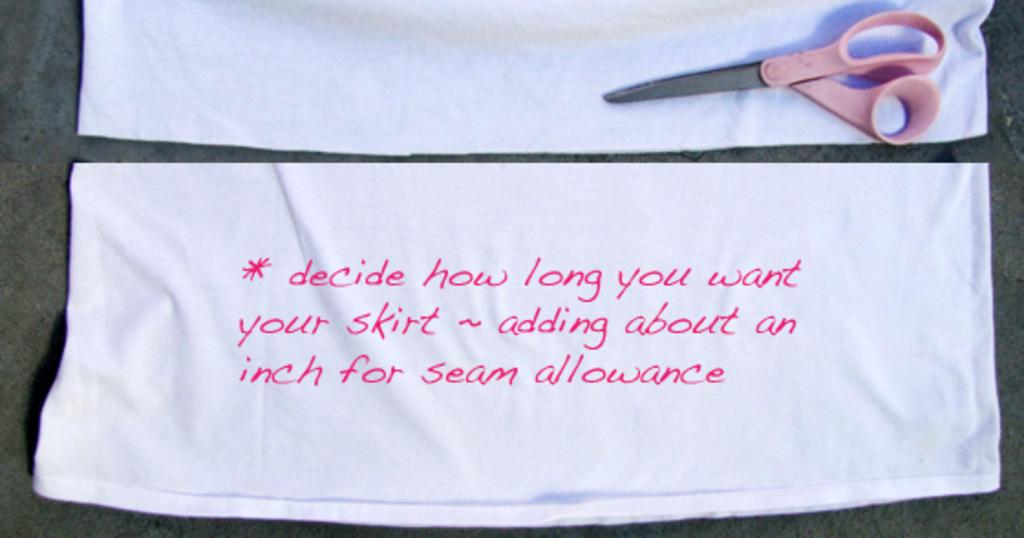What is written or printed on the white cloth in the image? There is text on a white cloth in the image. What object is placed on another white cloth in the image? There is a scissor on another white cloth in the image. What can be seen in the background of the image? There is a plain surface visible in the background of the image. How many giraffes are standing on the plain surface in the image? There are no giraffes present in the image. What type of honey is being used to write the text on the white cloth? There is no honey present in the image, and the text is not written with any substance. Is there a chessboard visible on the plain surface in the image? There is no chessboard present in the image. 